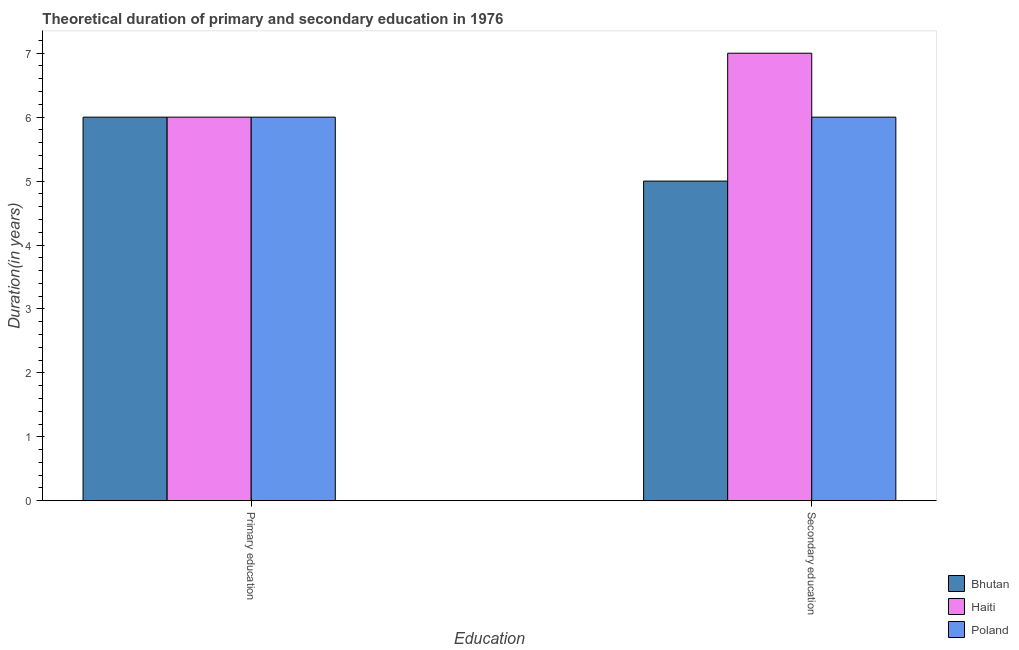How many bars are there on the 1st tick from the right?
Provide a succinct answer. 3. What is the label of the 1st group of bars from the left?
Your response must be concise. Primary education. What is the duration of secondary education in Haiti?
Provide a short and direct response. 7. Across all countries, what is the maximum duration of secondary education?
Give a very brief answer. 7. In which country was the duration of secondary education maximum?
Your answer should be very brief. Haiti. In which country was the duration of primary education minimum?
Give a very brief answer. Bhutan. What is the total duration of secondary education in the graph?
Your answer should be compact. 18. What is the difference between the duration of primary education in Haiti and that in Poland?
Keep it short and to the point. 0. What is the difference between the duration of secondary education in Bhutan and the duration of primary education in Haiti?
Offer a terse response. -1. What is the average duration of secondary education per country?
Make the answer very short. 6. What is the difference between the duration of secondary education and duration of primary education in Poland?
Give a very brief answer. 0. In how many countries, is the duration of secondary education greater than the average duration of secondary education taken over all countries?
Offer a very short reply. 1. What does the 1st bar from the left in Primary education represents?
Your answer should be very brief. Bhutan. What does the 1st bar from the right in Primary education represents?
Your answer should be very brief. Poland. How many bars are there?
Ensure brevity in your answer.  6. How many countries are there in the graph?
Offer a terse response. 3. What is the difference between two consecutive major ticks on the Y-axis?
Keep it short and to the point. 1. Are the values on the major ticks of Y-axis written in scientific E-notation?
Provide a succinct answer. No. How many legend labels are there?
Ensure brevity in your answer.  3. What is the title of the graph?
Give a very brief answer. Theoretical duration of primary and secondary education in 1976. What is the label or title of the X-axis?
Offer a terse response. Education. What is the label or title of the Y-axis?
Offer a terse response. Duration(in years). What is the Duration(in years) of Haiti in Primary education?
Offer a terse response. 6. What is the Duration(in years) in Haiti in Secondary education?
Keep it short and to the point. 7. What is the Duration(in years) in Poland in Secondary education?
Offer a very short reply. 6. Across all Education, what is the maximum Duration(in years) of Poland?
Give a very brief answer. 6. Across all Education, what is the minimum Duration(in years) in Haiti?
Give a very brief answer. 6. What is the total Duration(in years) in Bhutan in the graph?
Give a very brief answer. 11. What is the total Duration(in years) of Poland in the graph?
Keep it short and to the point. 12. What is the difference between the Duration(in years) of Bhutan in Primary education and that in Secondary education?
Your response must be concise. 1. What is the difference between the Duration(in years) in Poland in Primary education and that in Secondary education?
Provide a short and direct response. 0. What is the difference between the Duration(in years) of Bhutan in Primary education and the Duration(in years) of Haiti in Secondary education?
Provide a succinct answer. -1. What is the difference between the Duration(in years) in Bhutan in Primary education and the Duration(in years) in Poland in Secondary education?
Your answer should be compact. 0. What is the difference between the Duration(in years) of Haiti in Primary education and the Duration(in years) of Poland in Secondary education?
Offer a very short reply. 0. What is the average Duration(in years) in Haiti per Education?
Ensure brevity in your answer.  6.5. What is the difference between the Duration(in years) in Bhutan and Duration(in years) in Haiti in Primary education?
Your response must be concise. 0. What is the difference between the Duration(in years) in Bhutan and Duration(in years) in Poland in Primary education?
Your answer should be very brief. 0. What is the difference between the Duration(in years) of Haiti and Duration(in years) of Poland in Secondary education?
Give a very brief answer. 1. What is the ratio of the Duration(in years) of Poland in Primary education to that in Secondary education?
Make the answer very short. 1. What is the difference between the highest and the second highest Duration(in years) of Haiti?
Ensure brevity in your answer.  1. 